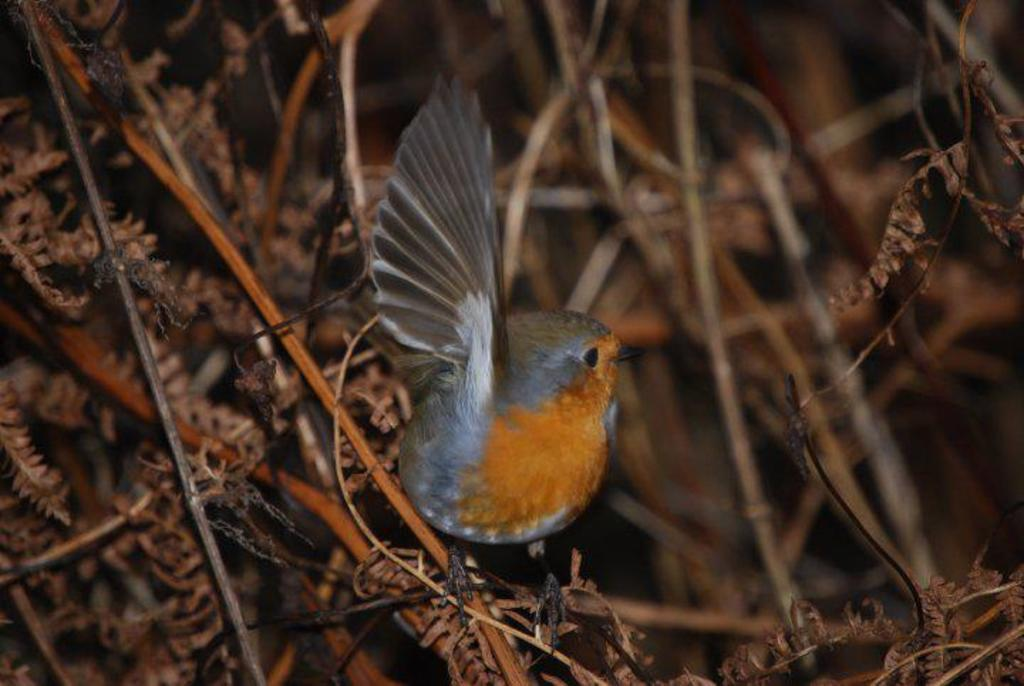What type of animal can be seen in the image? There is a bird in the image. What colors are present on the bird? The bird has orange, brown, grey, white, and black colors. Where is the bird located in the image? The bird is on a plant. What colors are present on the plant? The plant has brown and orange colors. How would you describe the background of the image? The background of the image is blurry. What type of wealth does the bird possess in the image? There is no indication of wealth in the image; it simply shows a bird on a plant. 